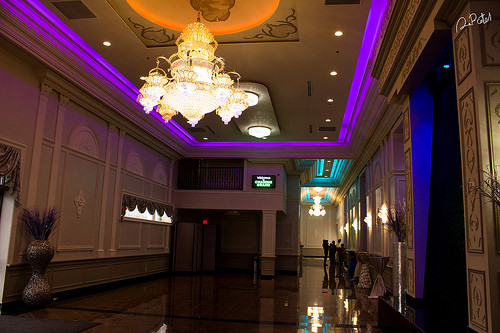<image>
Can you confirm if the vase is above the floor line? Yes. The vase is positioned above the floor line in the vertical space, higher up in the scene. 